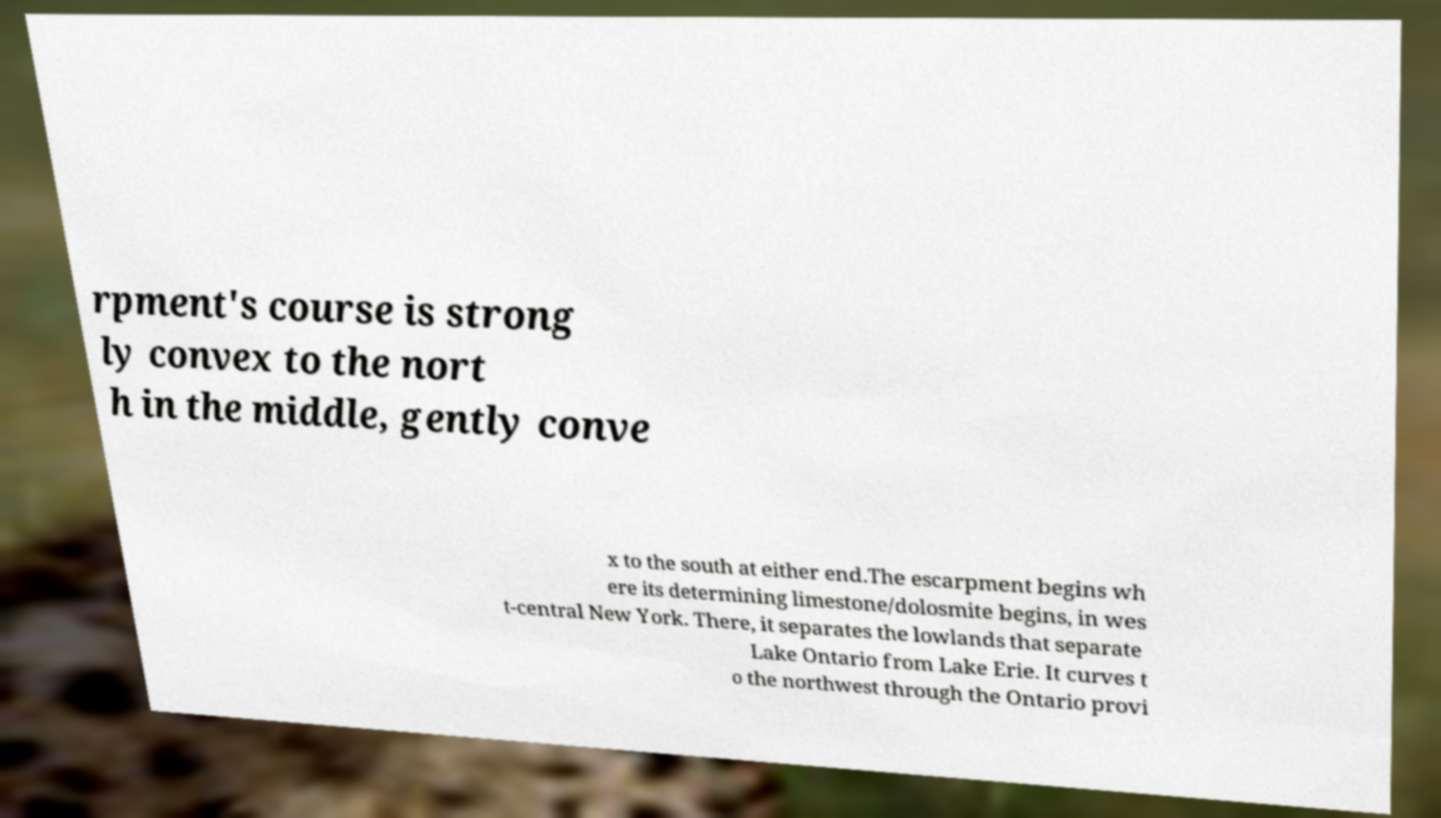What messages or text are displayed in this image? I need them in a readable, typed format. rpment's course is strong ly convex to the nort h in the middle, gently conve x to the south at either end.The escarpment begins wh ere its determining limestone/dolosmite begins, in wes t-central New York. There, it separates the lowlands that separate Lake Ontario from Lake Erie. It curves t o the northwest through the Ontario provi 